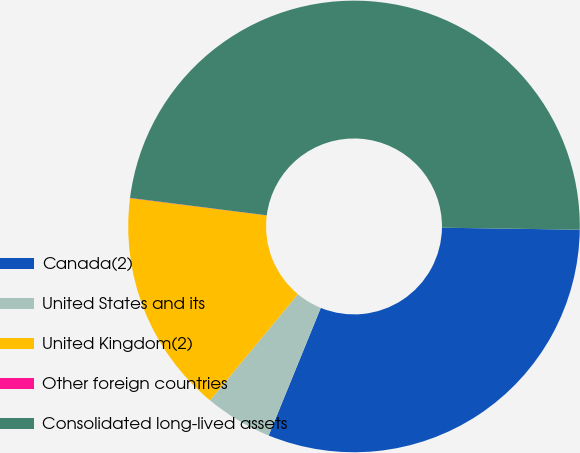<chart> <loc_0><loc_0><loc_500><loc_500><pie_chart><fcel>Canada(2)<fcel>United States and its<fcel>United Kingdom(2)<fcel>Other foreign countries<fcel>Consolidated long-lived assets<nl><fcel>30.94%<fcel>4.84%<fcel>15.99%<fcel>0.02%<fcel>48.21%<nl></chart> 